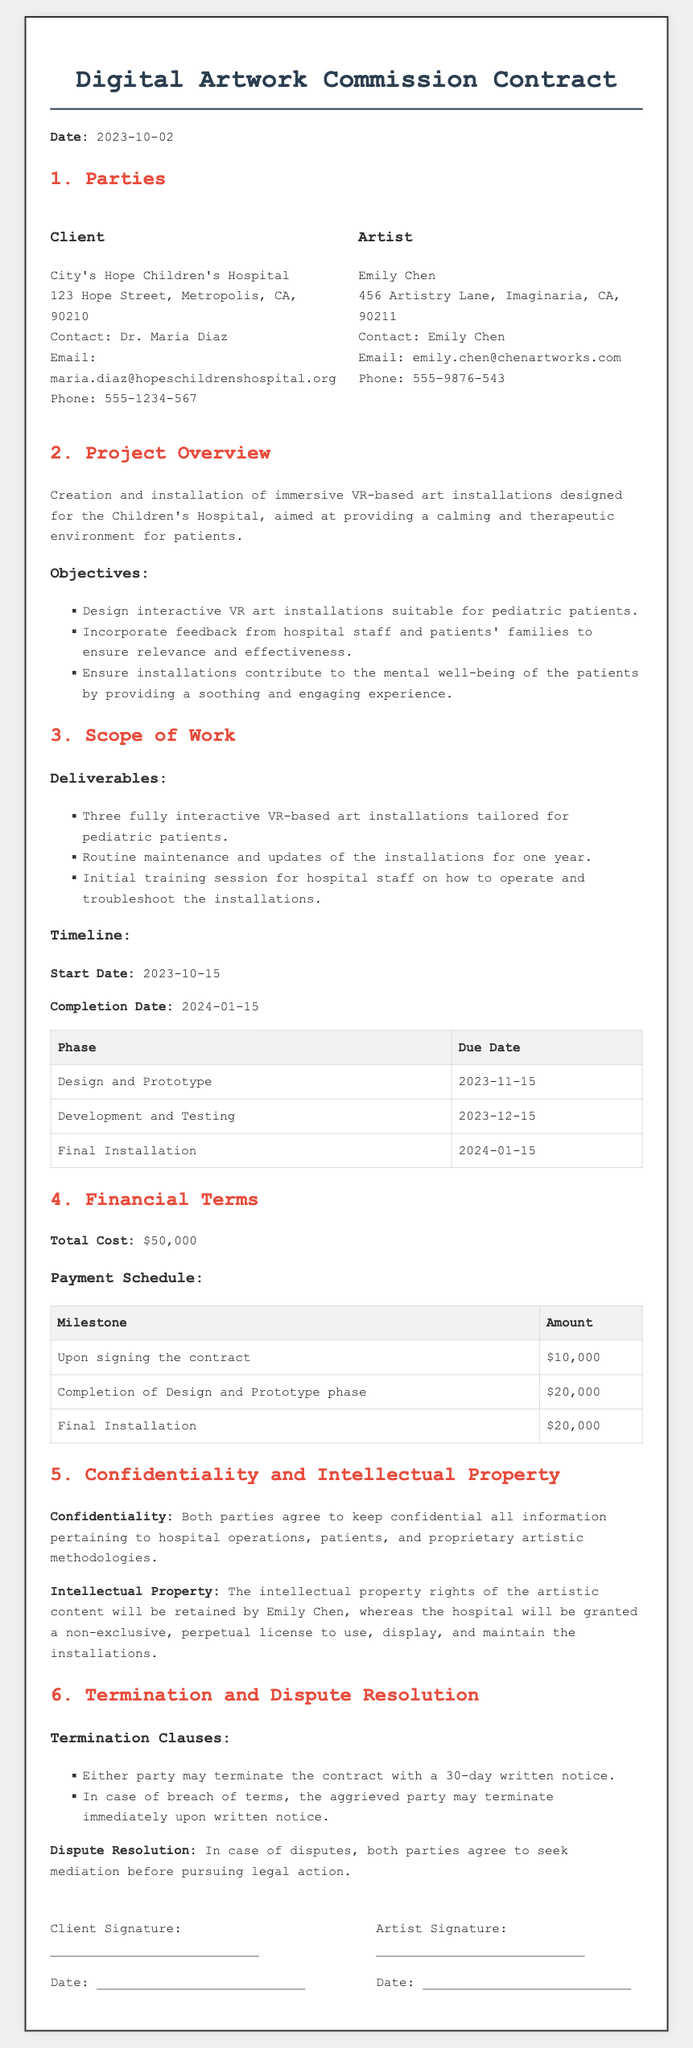what is the date of the contract? The date mentioned at the beginning of the contract is the official date it was made, which is 2023-10-02.
Answer: 2023-10-02 who is the artist? The contract lists Emily Chen as the artist who will create the VR-based art installations.
Answer: Emily Chen what is the start date of the project? The start date indicates when the project is scheduled to commence, which is 2023-10-15.
Answer: 2023-10-15 how many interactive installations will be created? The scope of work specifies the number of installations to be created, which is three.
Answer: three what is the total cost of the project? The financial terms clearly define the total monetary amount for the project, which is $50,000.
Answer: $50,000 what is the completion date of the project? The completion date indicates when the project is expected to be finished, which is 2024-01-15.
Answer: 2024-01-15 how long will maintenance and updates last? The deliverables section states the duration for maintenance and updates, which is one year.
Answer: one year what type of license does the hospital receive for the artwork? The intellectual property section describes the type of license granted to the hospital, which is non-exclusive and perpetual.
Answer: non-exclusive, perpetual what happens in case of a breach of terms? The termination section outlines the procedure if one party breaches the contract, specifying that the aggrieved party may terminate immediately upon written notice.
Answer: terminate immediately upon written notice 